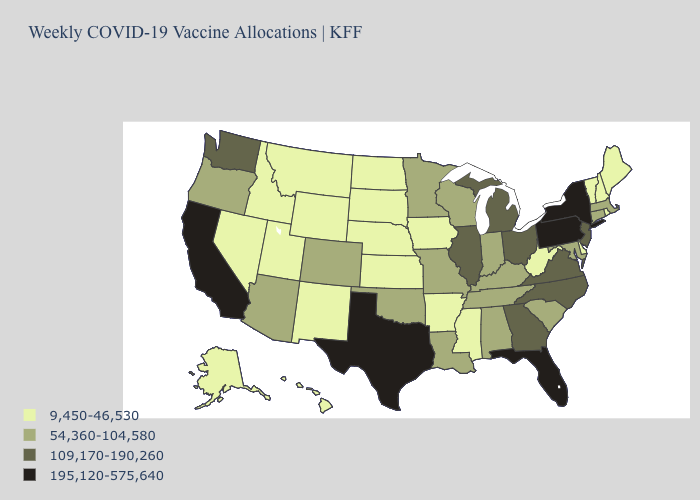What is the lowest value in states that border Maine?
Give a very brief answer. 9,450-46,530. Name the states that have a value in the range 195,120-575,640?
Give a very brief answer. California, Florida, New York, Pennsylvania, Texas. What is the value of Nebraska?
Concise answer only. 9,450-46,530. Does California have the highest value in the West?
Keep it brief. Yes. Name the states that have a value in the range 109,170-190,260?
Give a very brief answer. Georgia, Illinois, Michigan, New Jersey, North Carolina, Ohio, Virginia, Washington. Does Missouri have the lowest value in the MidWest?
Give a very brief answer. No. What is the value of Wyoming?
Keep it brief. 9,450-46,530. Does the first symbol in the legend represent the smallest category?
Quick response, please. Yes. How many symbols are there in the legend?
Short answer required. 4. Name the states that have a value in the range 9,450-46,530?
Concise answer only. Alaska, Arkansas, Delaware, Hawaii, Idaho, Iowa, Kansas, Maine, Mississippi, Montana, Nebraska, Nevada, New Hampshire, New Mexico, North Dakota, Rhode Island, South Dakota, Utah, Vermont, West Virginia, Wyoming. What is the value of Rhode Island?
Write a very short answer. 9,450-46,530. Name the states that have a value in the range 195,120-575,640?
Give a very brief answer. California, Florida, New York, Pennsylvania, Texas. Among the states that border New Hampshire , does Maine have the highest value?
Keep it brief. No. Among the states that border Minnesota , does Wisconsin have the highest value?
Answer briefly. Yes. Among the states that border Arkansas , which have the highest value?
Be succinct. Texas. 